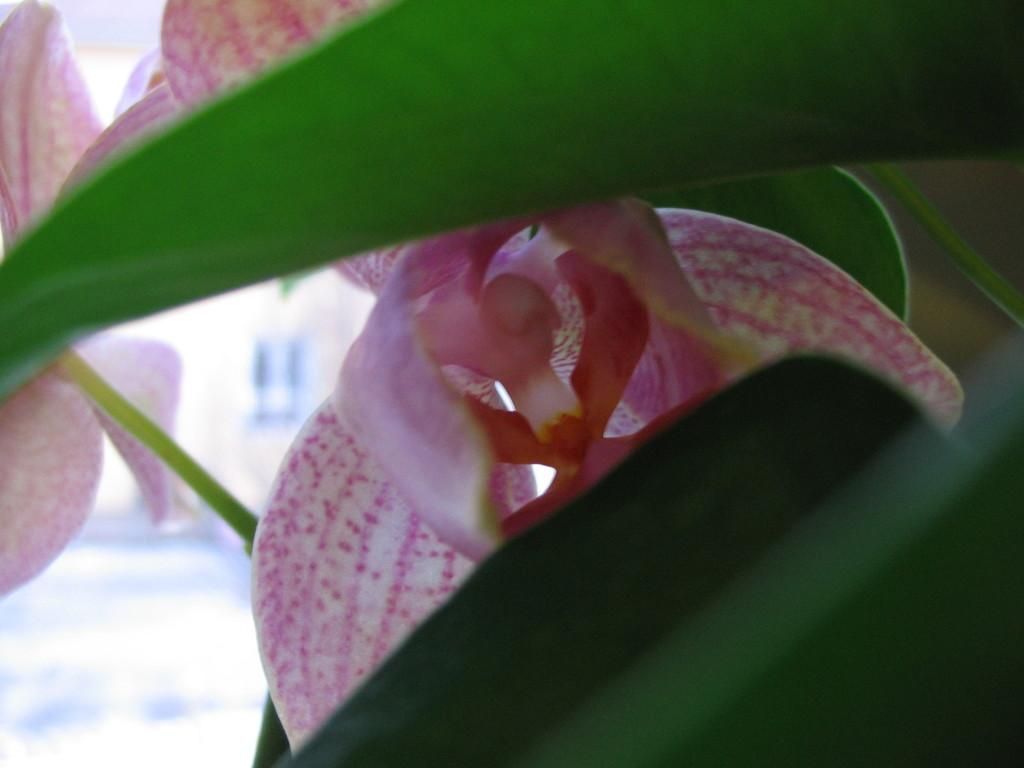What type of plants can be seen in the image? There are flowering plants in the image. What type of structure is visible in the image? There is a house in the image. Can you describe the time of day when the image was taken? The image was taken during the day. What color is the sock that the flowering plant is wearing in the image? There is no sock present in the image, as plants do not wear socks. What thought is the house having in the image? There is no indication of any thoughts in the image, as houses are inanimate objects and cannot have thoughts. 